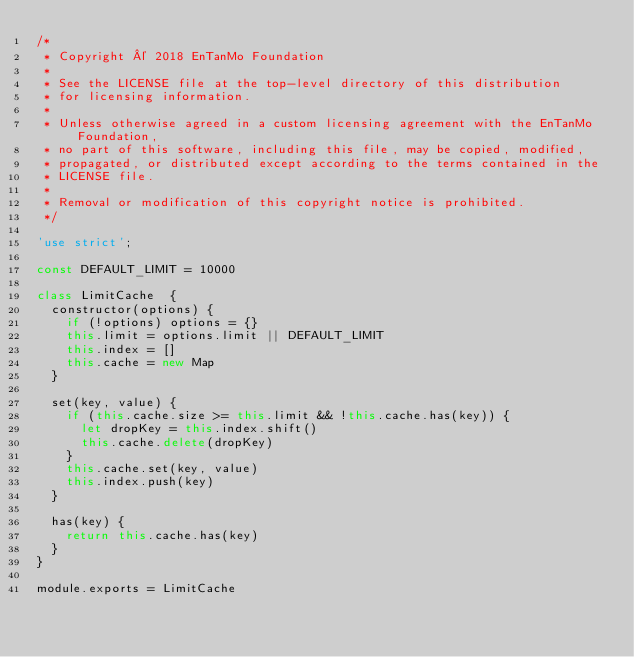<code> <loc_0><loc_0><loc_500><loc_500><_JavaScript_>/*
 * Copyright © 2018 EnTanMo Foundation
 *
 * See the LICENSE file at the top-level directory of this distribution
 * for licensing information.
 *
 * Unless otherwise agreed in a custom licensing agreement with the EnTanMo Foundation,
 * no part of this software, including this file, may be copied, modified,
 * propagated, or distributed except according to the terms contained in the
 * LICENSE file.
 *
 * Removal or modification of this copyright notice is prohibited.
 */

'use strict';

const DEFAULT_LIMIT = 10000

class LimitCache  {
  constructor(options) {
    if (!options) options = {}
    this.limit = options.limit || DEFAULT_LIMIT
    this.index = []
    this.cache = new Map
  }

  set(key, value) {
    if (this.cache.size >= this.limit && !this.cache.has(key)) {
      let dropKey = this.index.shift()
      this.cache.delete(dropKey)
    }
    this.cache.set(key, value)
    this.index.push(key)
  }

  has(key) {
    return this.cache.has(key)
  }
}

module.exports = LimitCache</code> 